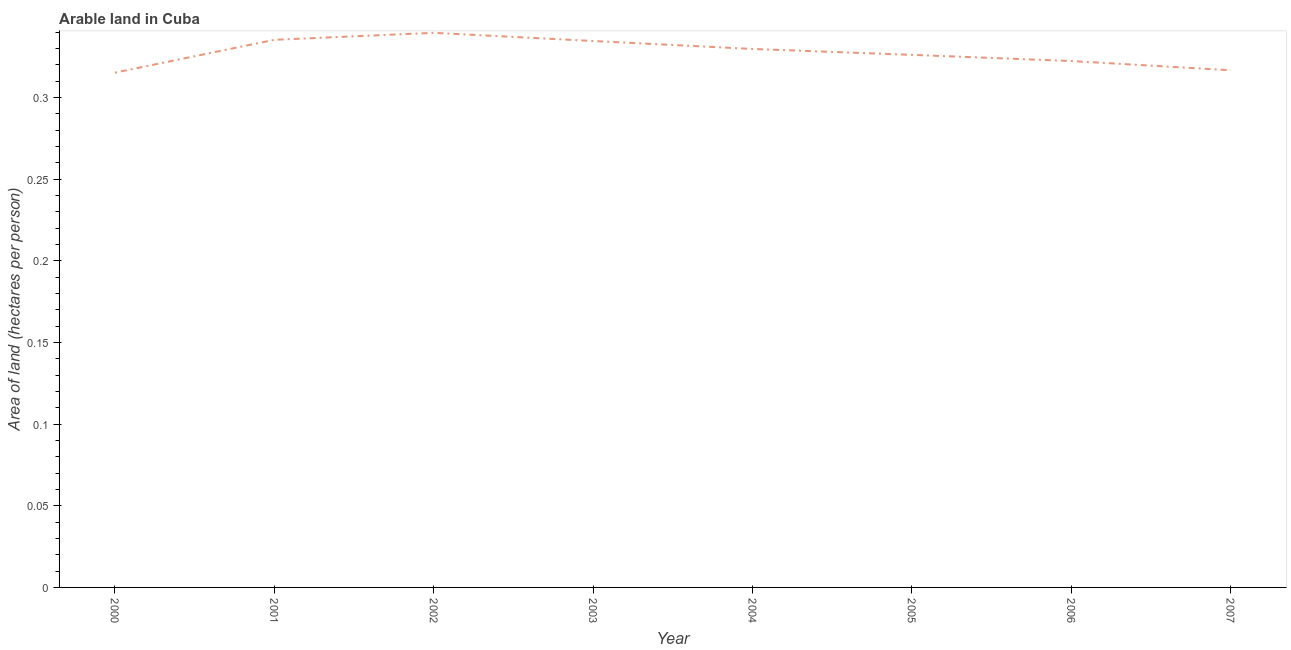What is the area of arable land in 2000?
Give a very brief answer. 0.32. Across all years, what is the maximum area of arable land?
Give a very brief answer. 0.34. Across all years, what is the minimum area of arable land?
Your answer should be very brief. 0.32. What is the sum of the area of arable land?
Provide a succinct answer. 2.62. What is the difference between the area of arable land in 2005 and 2006?
Ensure brevity in your answer.  0. What is the average area of arable land per year?
Provide a short and direct response. 0.33. What is the median area of arable land?
Ensure brevity in your answer.  0.33. In how many years, is the area of arable land greater than 0.15000000000000002 hectares per person?
Provide a succinct answer. 8. What is the ratio of the area of arable land in 2001 to that in 2007?
Make the answer very short. 1.06. Is the difference between the area of arable land in 2001 and 2003 greater than the difference between any two years?
Give a very brief answer. No. What is the difference between the highest and the second highest area of arable land?
Make the answer very short. 0. What is the difference between the highest and the lowest area of arable land?
Give a very brief answer. 0.02. How many lines are there?
Give a very brief answer. 1. How many years are there in the graph?
Ensure brevity in your answer.  8. Are the values on the major ticks of Y-axis written in scientific E-notation?
Give a very brief answer. No. Does the graph contain any zero values?
Keep it short and to the point. No. Does the graph contain grids?
Your response must be concise. No. What is the title of the graph?
Provide a succinct answer. Arable land in Cuba. What is the label or title of the Y-axis?
Offer a very short reply. Area of land (hectares per person). What is the Area of land (hectares per person) of 2000?
Provide a short and direct response. 0.32. What is the Area of land (hectares per person) in 2001?
Ensure brevity in your answer.  0.34. What is the Area of land (hectares per person) of 2002?
Provide a succinct answer. 0.34. What is the Area of land (hectares per person) in 2003?
Your answer should be very brief. 0.33. What is the Area of land (hectares per person) in 2004?
Give a very brief answer. 0.33. What is the Area of land (hectares per person) in 2005?
Keep it short and to the point. 0.33. What is the Area of land (hectares per person) of 2006?
Offer a very short reply. 0.32. What is the Area of land (hectares per person) of 2007?
Your response must be concise. 0.32. What is the difference between the Area of land (hectares per person) in 2000 and 2001?
Your answer should be very brief. -0.02. What is the difference between the Area of land (hectares per person) in 2000 and 2002?
Make the answer very short. -0.02. What is the difference between the Area of land (hectares per person) in 2000 and 2003?
Your answer should be very brief. -0.02. What is the difference between the Area of land (hectares per person) in 2000 and 2004?
Your answer should be very brief. -0.01. What is the difference between the Area of land (hectares per person) in 2000 and 2005?
Your answer should be very brief. -0.01. What is the difference between the Area of land (hectares per person) in 2000 and 2006?
Your answer should be compact. -0.01. What is the difference between the Area of land (hectares per person) in 2000 and 2007?
Make the answer very short. -0. What is the difference between the Area of land (hectares per person) in 2001 and 2002?
Offer a very short reply. -0. What is the difference between the Area of land (hectares per person) in 2001 and 2003?
Provide a succinct answer. 0. What is the difference between the Area of land (hectares per person) in 2001 and 2004?
Give a very brief answer. 0.01. What is the difference between the Area of land (hectares per person) in 2001 and 2005?
Make the answer very short. 0.01. What is the difference between the Area of land (hectares per person) in 2001 and 2006?
Your response must be concise. 0.01. What is the difference between the Area of land (hectares per person) in 2001 and 2007?
Provide a succinct answer. 0.02. What is the difference between the Area of land (hectares per person) in 2002 and 2003?
Offer a very short reply. 0.01. What is the difference between the Area of land (hectares per person) in 2002 and 2004?
Offer a very short reply. 0.01. What is the difference between the Area of land (hectares per person) in 2002 and 2005?
Offer a terse response. 0.01. What is the difference between the Area of land (hectares per person) in 2002 and 2006?
Your answer should be compact. 0.02. What is the difference between the Area of land (hectares per person) in 2002 and 2007?
Ensure brevity in your answer.  0.02. What is the difference between the Area of land (hectares per person) in 2003 and 2004?
Ensure brevity in your answer.  0. What is the difference between the Area of land (hectares per person) in 2003 and 2005?
Give a very brief answer. 0.01. What is the difference between the Area of land (hectares per person) in 2003 and 2006?
Ensure brevity in your answer.  0.01. What is the difference between the Area of land (hectares per person) in 2003 and 2007?
Provide a short and direct response. 0.02. What is the difference between the Area of land (hectares per person) in 2004 and 2005?
Make the answer very short. 0. What is the difference between the Area of land (hectares per person) in 2004 and 2006?
Your answer should be very brief. 0.01. What is the difference between the Area of land (hectares per person) in 2004 and 2007?
Offer a very short reply. 0.01. What is the difference between the Area of land (hectares per person) in 2005 and 2006?
Your response must be concise. 0. What is the difference between the Area of land (hectares per person) in 2005 and 2007?
Offer a terse response. 0.01. What is the difference between the Area of land (hectares per person) in 2006 and 2007?
Keep it short and to the point. 0.01. What is the ratio of the Area of land (hectares per person) in 2000 to that in 2001?
Provide a succinct answer. 0.94. What is the ratio of the Area of land (hectares per person) in 2000 to that in 2002?
Ensure brevity in your answer.  0.93. What is the ratio of the Area of land (hectares per person) in 2000 to that in 2003?
Offer a terse response. 0.94. What is the ratio of the Area of land (hectares per person) in 2000 to that in 2004?
Provide a succinct answer. 0.96. What is the ratio of the Area of land (hectares per person) in 2000 to that in 2005?
Make the answer very short. 0.97. What is the ratio of the Area of land (hectares per person) in 2000 to that in 2006?
Offer a very short reply. 0.98. What is the ratio of the Area of land (hectares per person) in 2001 to that in 2002?
Your answer should be very brief. 0.99. What is the ratio of the Area of land (hectares per person) in 2001 to that in 2005?
Give a very brief answer. 1.03. What is the ratio of the Area of land (hectares per person) in 2001 to that in 2007?
Provide a short and direct response. 1.06. What is the ratio of the Area of land (hectares per person) in 2002 to that in 2005?
Offer a very short reply. 1.04. What is the ratio of the Area of land (hectares per person) in 2002 to that in 2006?
Your answer should be very brief. 1.05. What is the ratio of the Area of land (hectares per person) in 2002 to that in 2007?
Offer a terse response. 1.07. What is the ratio of the Area of land (hectares per person) in 2003 to that in 2005?
Give a very brief answer. 1.03. What is the ratio of the Area of land (hectares per person) in 2003 to that in 2006?
Your answer should be very brief. 1.04. What is the ratio of the Area of land (hectares per person) in 2003 to that in 2007?
Provide a succinct answer. 1.06. What is the ratio of the Area of land (hectares per person) in 2004 to that in 2006?
Your answer should be compact. 1.02. What is the ratio of the Area of land (hectares per person) in 2004 to that in 2007?
Provide a short and direct response. 1.04. What is the ratio of the Area of land (hectares per person) in 2005 to that in 2007?
Offer a terse response. 1.03. 